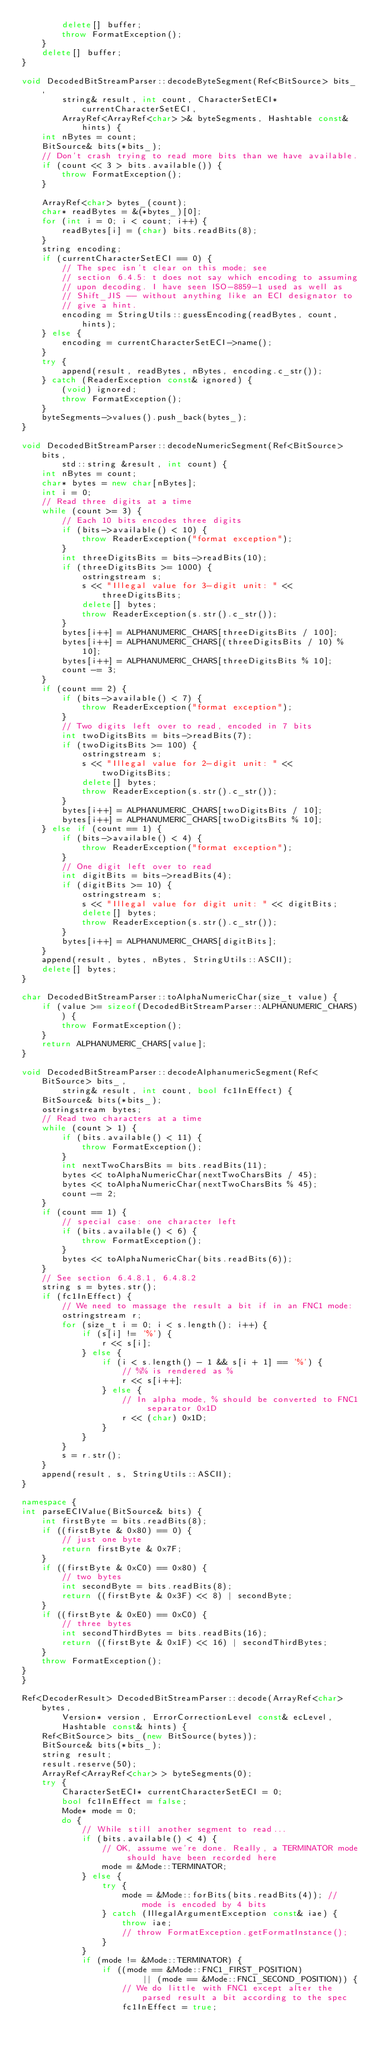Convert code to text. <code><loc_0><loc_0><loc_500><loc_500><_C++_>		delete[] buffer;
		throw FormatException();
	}
	delete[] buffer;
}

void DecodedBitStreamParser::decodeByteSegment(Ref<BitSource> bits_,
		string& result, int count, CharacterSetECI* currentCharacterSetECI,
		ArrayRef<ArrayRef<char> >& byteSegments, Hashtable const& hints) {
	int nBytes = count;
	BitSource& bits(*bits_);
	// Don't crash trying to read more bits than we have available.
	if (count << 3 > bits.available()) {
		throw FormatException();
	}

	ArrayRef<char> bytes_(count);
	char* readBytes = &(*bytes_)[0];
	for (int i = 0; i < count; i++) {
		readBytes[i] = (char) bits.readBits(8);
	}
	string encoding;
	if (currentCharacterSetECI == 0) {
		// The spec isn't clear on this mode; see
		// section 6.4.5: t does not say which encoding to assuming
		// upon decoding. I have seen ISO-8859-1 used as well as
		// Shift_JIS -- without anything like an ECI designator to
		// give a hint.
		encoding = StringUtils::guessEncoding(readBytes, count, hints);
	} else {
		encoding = currentCharacterSetECI->name();
	}
	try {
		append(result, readBytes, nBytes, encoding.c_str());
	} catch (ReaderException const& ignored) {
		(void) ignored;
		throw FormatException();
	}
	byteSegments->values().push_back(bytes_);
}

void DecodedBitStreamParser::decodeNumericSegment(Ref<BitSource> bits,
		std::string &result, int count) {
	int nBytes = count;
	char* bytes = new char[nBytes];
	int i = 0;
	// Read three digits at a time
	while (count >= 3) {
		// Each 10 bits encodes three digits
		if (bits->available() < 10) {
			throw ReaderException("format exception");
		}
		int threeDigitsBits = bits->readBits(10);
		if (threeDigitsBits >= 1000) {
			ostringstream s;
			s << "Illegal value for 3-digit unit: " << threeDigitsBits;
			delete[] bytes;
			throw ReaderException(s.str().c_str());
		}
		bytes[i++] = ALPHANUMERIC_CHARS[threeDigitsBits / 100];
		bytes[i++] = ALPHANUMERIC_CHARS[(threeDigitsBits / 10) % 10];
		bytes[i++] = ALPHANUMERIC_CHARS[threeDigitsBits % 10];
		count -= 3;
	}
	if (count == 2) {
		if (bits->available() < 7) {
			throw ReaderException("format exception");
		}
		// Two digits left over to read, encoded in 7 bits
		int twoDigitsBits = bits->readBits(7);
		if (twoDigitsBits >= 100) {
			ostringstream s;
			s << "Illegal value for 2-digit unit: " << twoDigitsBits;
			delete[] bytes;
			throw ReaderException(s.str().c_str());
		}
		bytes[i++] = ALPHANUMERIC_CHARS[twoDigitsBits / 10];
		bytes[i++] = ALPHANUMERIC_CHARS[twoDigitsBits % 10];
	} else if (count == 1) {
		if (bits->available() < 4) {
			throw ReaderException("format exception");
		}
		// One digit left over to read
		int digitBits = bits->readBits(4);
		if (digitBits >= 10) {
			ostringstream s;
			s << "Illegal value for digit unit: " << digitBits;
			delete[] bytes;
			throw ReaderException(s.str().c_str());
		}
		bytes[i++] = ALPHANUMERIC_CHARS[digitBits];
	}
	append(result, bytes, nBytes, StringUtils::ASCII);
	delete[] bytes;
}

char DecodedBitStreamParser::toAlphaNumericChar(size_t value) {
	if (value >= sizeof(DecodedBitStreamParser::ALPHANUMERIC_CHARS)) {
		throw FormatException();
	}
	return ALPHANUMERIC_CHARS[value];
}

void DecodedBitStreamParser::decodeAlphanumericSegment(Ref<BitSource> bits_,
		string& result, int count, bool fc1InEffect) {
	BitSource& bits(*bits_);
	ostringstream bytes;
	// Read two characters at a time
	while (count > 1) {
		if (bits.available() < 11) {
			throw FormatException();
		}
		int nextTwoCharsBits = bits.readBits(11);
		bytes << toAlphaNumericChar(nextTwoCharsBits / 45);
		bytes << toAlphaNumericChar(nextTwoCharsBits % 45);
		count -= 2;
	}
	if (count == 1) {
		// special case: one character left
		if (bits.available() < 6) {
			throw FormatException();
		}
		bytes << toAlphaNumericChar(bits.readBits(6));
	}
	// See section 6.4.8.1, 6.4.8.2
	string s = bytes.str();
	if (fc1InEffect) {
		// We need to massage the result a bit if in an FNC1 mode:
		ostringstream r;
		for (size_t i = 0; i < s.length(); i++) {
			if (s[i] != '%') {
				r << s[i];
			} else {
				if (i < s.length() - 1 && s[i + 1] == '%') {
					// %% is rendered as %
					r << s[i++];
				} else {
					// In alpha mode, % should be converted to FNC1 separator 0x1D
					r << (char) 0x1D;
				}
			}
		}
		s = r.str();
	}
	append(result, s, StringUtils::ASCII);
}

namespace {
int parseECIValue(BitSource& bits) {
	int firstByte = bits.readBits(8);
	if ((firstByte & 0x80) == 0) {
		// just one byte
		return firstByte & 0x7F;
	}
	if ((firstByte & 0xC0) == 0x80) {
		// two bytes
		int secondByte = bits.readBits(8);
		return ((firstByte & 0x3F) << 8) | secondByte;
	}
	if ((firstByte & 0xE0) == 0xC0) {
		// three bytes
		int secondThirdBytes = bits.readBits(16);
		return ((firstByte & 0x1F) << 16) | secondThirdBytes;
	}
	throw FormatException();
}
}

Ref<DecoderResult> DecodedBitStreamParser::decode(ArrayRef<char> bytes,
		Version* version, ErrorCorrectionLevel const& ecLevel,
		Hashtable const& hints) {
	Ref<BitSource> bits_(new BitSource(bytes));
	BitSource& bits(*bits_);
	string result;
	result.reserve(50);
	ArrayRef<ArrayRef<char> > byteSegments(0);
	try {
		CharacterSetECI* currentCharacterSetECI = 0;
		bool fc1InEffect = false;
		Mode* mode = 0;
		do {
			// While still another segment to read...
			if (bits.available() < 4) {
				// OK, assume we're done. Really, a TERMINATOR mode should have been recorded here
				mode = &Mode::TERMINATOR;
			} else {
				try {
					mode = &Mode::forBits(bits.readBits(4)); // mode is encoded by 4 bits
				} catch (IllegalArgumentException const& iae) {
					throw iae;
					// throw FormatException.getFormatInstance();
				}
			}
			if (mode != &Mode::TERMINATOR) {
				if ((mode == &Mode::FNC1_FIRST_POSITION)
						|| (mode == &Mode::FNC1_SECOND_POSITION)) {
					// We do little with FNC1 except alter the parsed result a bit according to the spec
					fc1InEffect = true;</code> 